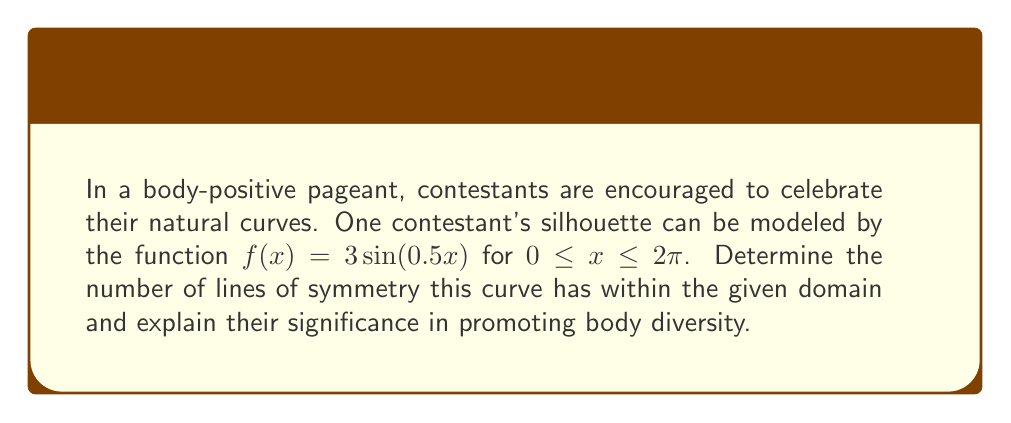What is the answer to this math problem? Let's approach this step-by-step:

1) The general sine function $y = \sin(x)$ has a period of $2\pi$. In our case, we have $f(x) = 3\sin(0.5x)$.

2) To find the period of our function, we use the formula:
   Period = $\frac{2\pi}{|b|}$, where $b$ is the coefficient of $x$ inside the sine function.
   Here, $b = 0.5$, so the period is $\frac{2\pi}{|0.5|} = 4\pi$

3) Within our given domain $[0, 2\pi]$, we have half of a complete period.

4) The sine function has two types of symmetry within a full period:
   a) Odd symmetry about the midpoint of the period
   b) Even symmetry about the quarter and three-quarter points of the period

5) In our half-period, we will have:
   - Odd symmetry about the midpoint: $x = \pi$
   - Even symmetry about the quarter point: $x = \frac{\pi}{2}$

6) These lines of symmetry can be verified by:
   $f(\pi + x) = 3\sin(0.5(\pi + x)) = 3\sin(0.5\pi + 0.5x) = 3\cos(0.5x) = -f(\pi - x)$ (odd symmetry)
   $f(\frac{\pi}{2} + x) = 3\sin(0.25\pi + 0.5x) = 3\sin(0.25\pi - 0.5x) = f(\frac{\pi}{2} - x)$ (even symmetry)

7) The significance in promoting body diversity:
   - The odd symmetry line represents the central axis of the body, emphasizing balance.
   - The even symmetry line highlights the natural curves on either side, celebrating the unique shape of each individual.

Therefore, there are 2 lines of symmetry within the given domain, each promoting a different aspect of body diversity and positivity.
Answer: 2 lines of symmetry 